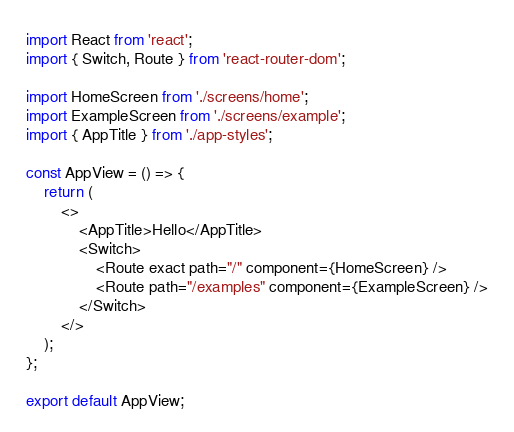Convert code to text. <code><loc_0><loc_0><loc_500><loc_500><_TypeScript_>import React from 'react';
import { Switch, Route } from 'react-router-dom';

import HomeScreen from './screens/home';
import ExampleScreen from './screens/example';
import { AppTitle } from './app-styles';

const AppView = () => {
	return (
		<>
			<AppTitle>Hello</AppTitle>
			<Switch>
				<Route exact path="/" component={HomeScreen} />
				<Route path="/examples" component={ExampleScreen} />
			</Switch>
		</>
	);
};

export default AppView;
</code> 